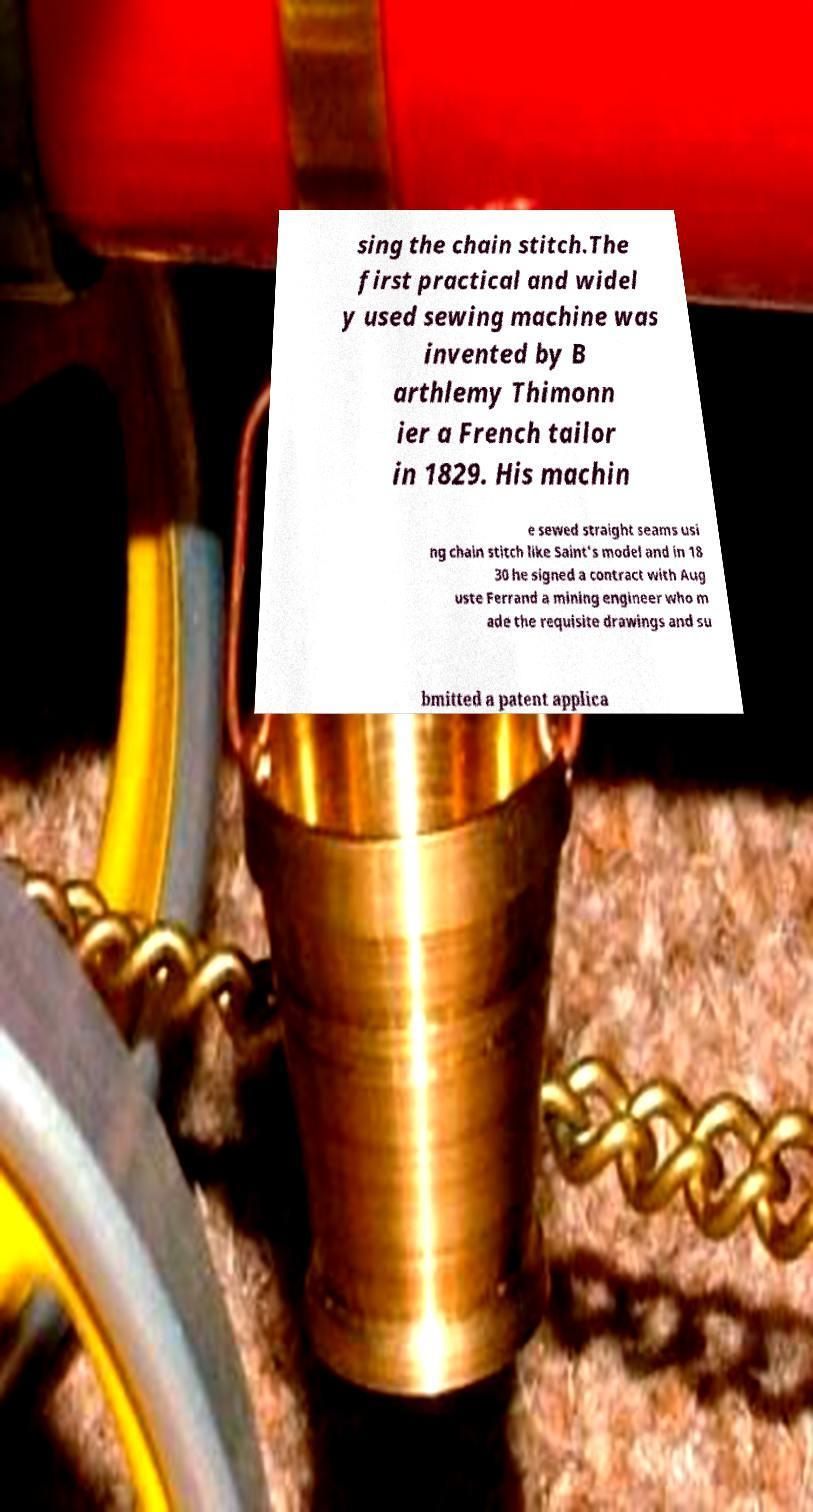Could you assist in decoding the text presented in this image and type it out clearly? sing the chain stitch.The first practical and widel y used sewing machine was invented by B arthlemy Thimonn ier a French tailor in 1829. His machin e sewed straight seams usi ng chain stitch like Saint's model and in 18 30 he signed a contract with Aug uste Ferrand a mining engineer who m ade the requisite drawings and su bmitted a patent applica 